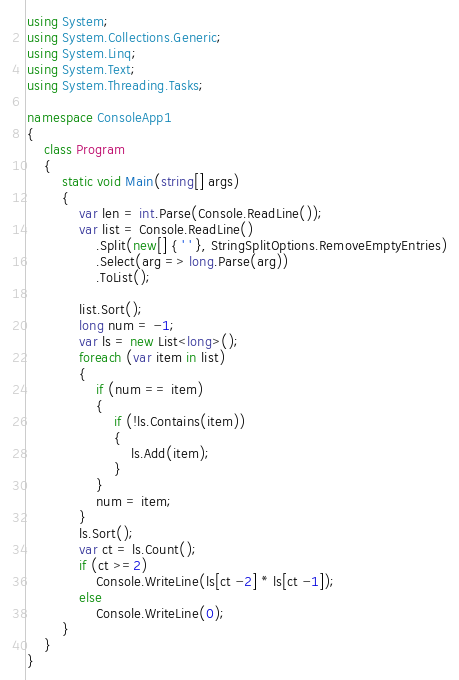Convert code to text. <code><loc_0><loc_0><loc_500><loc_500><_C#_>using System;
using System.Collections.Generic;
using System.Linq;
using System.Text;
using System.Threading.Tasks;

namespace ConsoleApp1
{
    class Program
    {
        static void Main(string[] args)
        {
            var len = int.Parse(Console.ReadLine());
            var list = Console.ReadLine()
                .Split(new[] { ' ' }, StringSplitOptions.RemoveEmptyEntries)
                .Select(arg => long.Parse(arg))
                .ToList();

            list.Sort();
            long num = -1;
            var ls = new List<long>();
            foreach (var item in list)
            {
                if (num == item)
                {
                    if (!ls.Contains(item))
                    {
                        ls.Add(item);
                    }
                }
                num = item;
            }
            ls.Sort();
            var ct = ls.Count();
            if (ct >=2)
                Console.WriteLine(ls[ct -2] * ls[ct -1]);
            else
                Console.WriteLine(0);
        }
    }
}</code> 